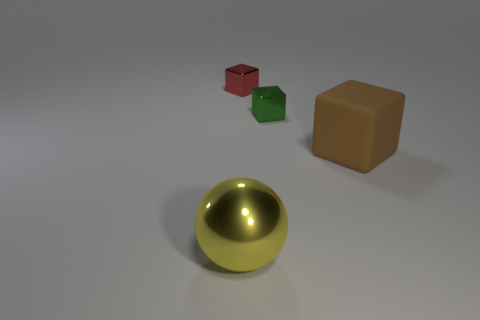How many rubber objects are tiny purple cylinders or yellow things?
Offer a terse response. 0. What number of large balls are to the left of the big object that is on the left side of the brown rubber cube?
Keep it short and to the point. 0. What number of objects are large blue metal cylinders or large objects that are left of the matte block?
Your answer should be very brief. 1. Are there any blue cylinders that have the same material as the brown object?
Give a very brief answer. No. How many things are on the left side of the brown cube and in front of the tiny green object?
Your answer should be very brief. 1. What material is the large object that is to the right of the big metallic object?
Make the answer very short. Rubber. There is a ball that is made of the same material as the green thing; what is its size?
Make the answer very short. Large. Are there any green metallic objects behind the large brown rubber thing?
Give a very brief answer. Yes. There is a brown object that is the same shape as the red thing; what size is it?
Provide a succinct answer. Large. Are there fewer big rubber objects than tiny objects?
Provide a short and direct response. Yes. 